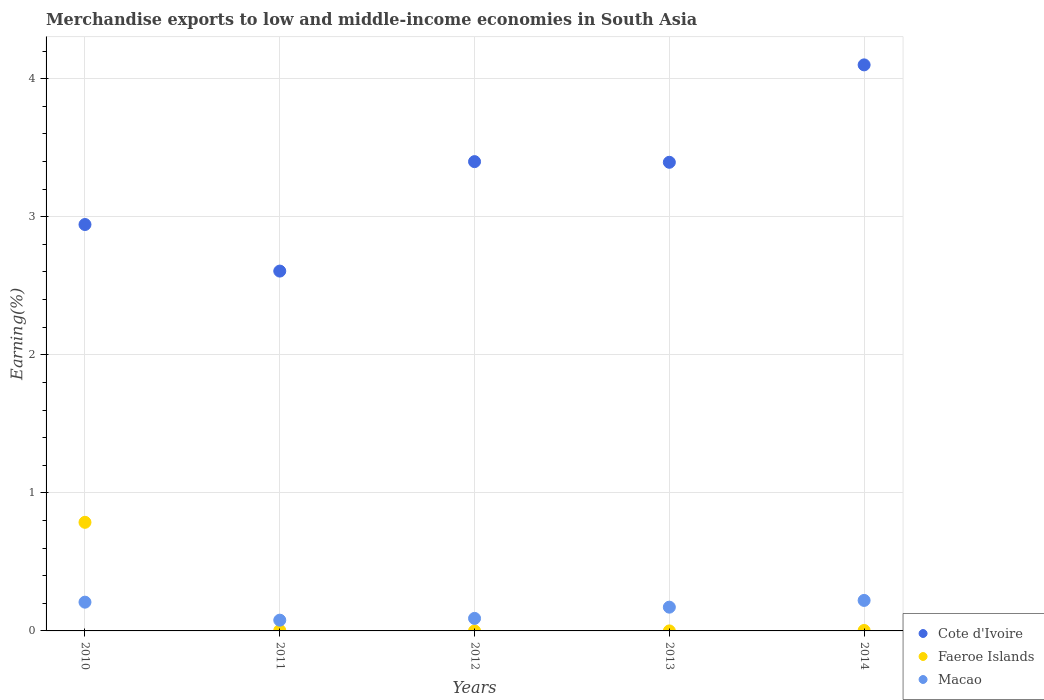Is the number of dotlines equal to the number of legend labels?
Give a very brief answer. Yes. What is the percentage of amount earned from merchandise exports in Faeroe Islands in 2010?
Your answer should be compact. 0.79. Across all years, what is the maximum percentage of amount earned from merchandise exports in Cote d'Ivoire?
Make the answer very short. 4.1. Across all years, what is the minimum percentage of amount earned from merchandise exports in Cote d'Ivoire?
Ensure brevity in your answer.  2.61. In which year was the percentage of amount earned from merchandise exports in Macao maximum?
Make the answer very short. 2014. What is the total percentage of amount earned from merchandise exports in Faeroe Islands in the graph?
Offer a terse response. 0.79. What is the difference between the percentage of amount earned from merchandise exports in Macao in 2010 and that in 2011?
Your response must be concise. 0.13. What is the difference between the percentage of amount earned from merchandise exports in Macao in 2012 and the percentage of amount earned from merchandise exports in Faeroe Islands in 2010?
Provide a short and direct response. -0.7. What is the average percentage of amount earned from merchandise exports in Macao per year?
Keep it short and to the point. 0.15. In the year 2013, what is the difference between the percentage of amount earned from merchandise exports in Faeroe Islands and percentage of amount earned from merchandise exports in Macao?
Your answer should be very brief. -0.17. In how many years, is the percentage of amount earned from merchandise exports in Macao greater than 3.6 %?
Provide a succinct answer. 0. What is the ratio of the percentage of amount earned from merchandise exports in Macao in 2010 to that in 2011?
Give a very brief answer. 2.67. Is the percentage of amount earned from merchandise exports in Macao in 2011 less than that in 2014?
Keep it short and to the point. Yes. What is the difference between the highest and the second highest percentage of amount earned from merchandise exports in Macao?
Keep it short and to the point. 0.01. What is the difference between the highest and the lowest percentage of amount earned from merchandise exports in Macao?
Make the answer very short. 0.14. In how many years, is the percentage of amount earned from merchandise exports in Cote d'Ivoire greater than the average percentage of amount earned from merchandise exports in Cote d'Ivoire taken over all years?
Provide a succinct answer. 3. Is the sum of the percentage of amount earned from merchandise exports in Cote d'Ivoire in 2011 and 2013 greater than the maximum percentage of amount earned from merchandise exports in Macao across all years?
Offer a very short reply. Yes. Is the percentage of amount earned from merchandise exports in Cote d'Ivoire strictly greater than the percentage of amount earned from merchandise exports in Macao over the years?
Offer a very short reply. Yes. Is the percentage of amount earned from merchandise exports in Faeroe Islands strictly less than the percentage of amount earned from merchandise exports in Macao over the years?
Provide a succinct answer. No. How many years are there in the graph?
Offer a very short reply. 5. Does the graph contain any zero values?
Provide a succinct answer. No. Does the graph contain grids?
Ensure brevity in your answer.  Yes. How many legend labels are there?
Make the answer very short. 3. How are the legend labels stacked?
Offer a very short reply. Vertical. What is the title of the graph?
Offer a terse response. Merchandise exports to low and middle-income economies in South Asia. Does "Luxembourg" appear as one of the legend labels in the graph?
Offer a very short reply. No. What is the label or title of the X-axis?
Your answer should be very brief. Years. What is the label or title of the Y-axis?
Your answer should be very brief. Earning(%). What is the Earning(%) in Cote d'Ivoire in 2010?
Ensure brevity in your answer.  2.94. What is the Earning(%) in Faeroe Islands in 2010?
Your answer should be very brief. 0.79. What is the Earning(%) of Macao in 2010?
Keep it short and to the point. 0.21. What is the Earning(%) of Cote d'Ivoire in 2011?
Provide a succinct answer. 2.61. What is the Earning(%) in Faeroe Islands in 2011?
Your answer should be very brief. 0. What is the Earning(%) in Macao in 2011?
Your answer should be compact. 0.08. What is the Earning(%) in Cote d'Ivoire in 2012?
Provide a short and direct response. 3.4. What is the Earning(%) of Faeroe Islands in 2012?
Give a very brief answer. 1.9199162385165e-5. What is the Earning(%) of Macao in 2012?
Ensure brevity in your answer.  0.09. What is the Earning(%) in Cote d'Ivoire in 2013?
Keep it short and to the point. 3.39. What is the Earning(%) in Faeroe Islands in 2013?
Your response must be concise. 3.45425076953635e-5. What is the Earning(%) of Macao in 2013?
Ensure brevity in your answer.  0.17. What is the Earning(%) in Cote d'Ivoire in 2014?
Your response must be concise. 4.1. What is the Earning(%) in Faeroe Islands in 2014?
Make the answer very short. 0. What is the Earning(%) of Macao in 2014?
Offer a terse response. 0.22. Across all years, what is the maximum Earning(%) of Cote d'Ivoire?
Your answer should be very brief. 4.1. Across all years, what is the maximum Earning(%) in Faeroe Islands?
Give a very brief answer. 0.79. Across all years, what is the maximum Earning(%) in Macao?
Your answer should be very brief. 0.22. Across all years, what is the minimum Earning(%) of Cote d'Ivoire?
Offer a terse response. 2.61. Across all years, what is the minimum Earning(%) of Faeroe Islands?
Ensure brevity in your answer.  1.9199162385165e-5. Across all years, what is the minimum Earning(%) of Macao?
Provide a succinct answer. 0.08. What is the total Earning(%) of Cote d'Ivoire in the graph?
Make the answer very short. 16.44. What is the total Earning(%) in Faeroe Islands in the graph?
Keep it short and to the point. 0.79. What is the total Earning(%) in Macao in the graph?
Offer a terse response. 0.77. What is the difference between the Earning(%) in Cote d'Ivoire in 2010 and that in 2011?
Provide a succinct answer. 0.34. What is the difference between the Earning(%) in Faeroe Islands in 2010 and that in 2011?
Ensure brevity in your answer.  0.78. What is the difference between the Earning(%) in Macao in 2010 and that in 2011?
Your answer should be compact. 0.13. What is the difference between the Earning(%) of Cote d'Ivoire in 2010 and that in 2012?
Offer a very short reply. -0.46. What is the difference between the Earning(%) of Faeroe Islands in 2010 and that in 2012?
Your response must be concise. 0.79. What is the difference between the Earning(%) of Macao in 2010 and that in 2012?
Provide a succinct answer. 0.12. What is the difference between the Earning(%) of Cote d'Ivoire in 2010 and that in 2013?
Your answer should be very brief. -0.45. What is the difference between the Earning(%) in Faeroe Islands in 2010 and that in 2013?
Your answer should be compact. 0.79. What is the difference between the Earning(%) in Macao in 2010 and that in 2013?
Keep it short and to the point. 0.04. What is the difference between the Earning(%) in Cote d'Ivoire in 2010 and that in 2014?
Make the answer very short. -1.16. What is the difference between the Earning(%) of Faeroe Islands in 2010 and that in 2014?
Provide a succinct answer. 0.78. What is the difference between the Earning(%) of Macao in 2010 and that in 2014?
Ensure brevity in your answer.  -0.01. What is the difference between the Earning(%) in Cote d'Ivoire in 2011 and that in 2012?
Keep it short and to the point. -0.79. What is the difference between the Earning(%) in Faeroe Islands in 2011 and that in 2012?
Provide a succinct answer. 0. What is the difference between the Earning(%) in Macao in 2011 and that in 2012?
Your answer should be compact. -0.01. What is the difference between the Earning(%) in Cote d'Ivoire in 2011 and that in 2013?
Your response must be concise. -0.79. What is the difference between the Earning(%) of Faeroe Islands in 2011 and that in 2013?
Provide a short and direct response. 0. What is the difference between the Earning(%) of Macao in 2011 and that in 2013?
Offer a very short reply. -0.09. What is the difference between the Earning(%) of Cote d'Ivoire in 2011 and that in 2014?
Ensure brevity in your answer.  -1.49. What is the difference between the Earning(%) in Macao in 2011 and that in 2014?
Ensure brevity in your answer.  -0.14. What is the difference between the Earning(%) in Cote d'Ivoire in 2012 and that in 2013?
Give a very brief answer. 0. What is the difference between the Earning(%) of Faeroe Islands in 2012 and that in 2013?
Provide a succinct answer. -0. What is the difference between the Earning(%) of Macao in 2012 and that in 2013?
Offer a very short reply. -0.08. What is the difference between the Earning(%) in Cote d'Ivoire in 2012 and that in 2014?
Keep it short and to the point. -0.7. What is the difference between the Earning(%) in Faeroe Islands in 2012 and that in 2014?
Keep it short and to the point. -0. What is the difference between the Earning(%) in Macao in 2012 and that in 2014?
Give a very brief answer. -0.13. What is the difference between the Earning(%) in Cote d'Ivoire in 2013 and that in 2014?
Keep it short and to the point. -0.71. What is the difference between the Earning(%) of Faeroe Islands in 2013 and that in 2014?
Provide a short and direct response. -0. What is the difference between the Earning(%) of Macao in 2013 and that in 2014?
Provide a short and direct response. -0.05. What is the difference between the Earning(%) of Cote d'Ivoire in 2010 and the Earning(%) of Faeroe Islands in 2011?
Provide a succinct answer. 2.94. What is the difference between the Earning(%) in Cote d'Ivoire in 2010 and the Earning(%) in Macao in 2011?
Provide a short and direct response. 2.87. What is the difference between the Earning(%) in Faeroe Islands in 2010 and the Earning(%) in Macao in 2011?
Keep it short and to the point. 0.71. What is the difference between the Earning(%) in Cote d'Ivoire in 2010 and the Earning(%) in Faeroe Islands in 2012?
Your answer should be compact. 2.94. What is the difference between the Earning(%) of Cote d'Ivoire in 2010 and the Earning(%) of Macao in 2012?
Offer a very short reply. 2.85. What is the difference between the Earning(%) of Faeroe Islands in 2010 and the Earning(%) of Macao in 2012?
Make the answer very short. 0.7. What is the difference between the Earning(%) in Cote d'Ivoire in 2010 and the Earning(%) in Faeroe Islands in 2013?
Offer a very short reply. 2.94. What is the difference between the Earning(%) in Cote d'Ivoire in 2010 and the Earning(%) in Macao in 2013?
Ensure brevity in your answer.  2.77. What is the difference between the Earning(%) of Faeroe Islands in 2010 and the Earning(%) of Macao in 2013?
Provide a short and direct response. 0.61. What is the difference between the Earning(%) in Cote d'Ivoire in 2010 and the Earning(%) in Faeroe Islands in 2014?
Offer a terse response. 2.94. What is the difference between the Earning(%) of Cote d'Ivoire in 2010 and the Earning(%) of Macao in 2014?
Your response must be concise. 2.72. What is the difference between the Earning(%) in Faeroe Islands in 2010 and the Earning(%) in Macao in 2014?
Provide a succinct answer. 0.57. What is the difference between the Earning(%) of Cote d'Ivoire in 2011 and the Earning(%) of Faeroe Islands in 2012?
Your answer should be compact. 2.61. What is the difference between the Earning(%) of Cote d'Ivoire in 2011 and the Earning(%) of Macao in 2012?
Ensure brevity in your answer.  2.52. What is the difference between the Earning(%) in Faeroe Islands in 2011 and the Earning(%) in Macao in 2012?
Provide a short and direct response. -0.09. What is the difference between the Earning(%) in Cote d'Ivoire in 2011 and the Earning(%) in Faeroe Islands in 2013?
Ensure brevity in your answer.  2.61. What is the difference between the Earning(%) of Cote d'Ivoire in 2011 and the Earning(%) of Macao in 2013?
Give a very brief answer. 2.43. What is the difference between the Earning(%) in Faeroe Islands in 2011 and the Earning(%) in Macao in 2013?
Provide a succinct answer. -0.17. What is the difference between the Earning(%) in Cote d'Ivoire in 2011 and the Earning(%) in Faeroe Islands in 2014?
Provide a succinct answer. 2.6. What is the difference between the Earning(%) of Cote d'Ivoire in 2011 and the Earning(%) of Macao in 2014?
Make the answer very short. 2.39. What is the difference between the Earning(%) in Faeroe Islands in 2011 and the Earning(%) in Macao in 2014?
Provide a succinct answer. -0.22. What is the difference between the Earning(%) of Cote d'Ivoire in 2012 and the Earning(%) of Faeroe Islands in 2013?
Provide a short and direct response. 3.4. What is the difference between the Earning(%) of Cote d'Ivoire in 2012 and the Earning(%) of Macao in 2013?
Ensure brevity in your answer.  3.23. What is the difference between the Earning(%) in Faeroe Islands in 2012 and the Earning(%) in Macao in 2013?
Keep it short and to the point. -0.17. What is the difference between the Earning(%) of Cote d'Ivoire in 2012 and the Earning(%) of Faeroe Islands in 2014?
Give a very brief answer. 3.4. What is the difference between the Earning(%) in Cote d'Ivoire in 2012 and the Earning(%) in Macao in 2014?
Your answer should be very brief. 3.18. What is the difference between the Earning(%) in Faeroe Islands in 2012 and the Earning(%) in Macao in 2014?
Ensure brevity in your answer.  -0.22. What is the difference between the Earning(%) of Cote d'Ivoire in 2013 and the Earning(%) of Faeroe Islands in 2014?
Provide a succinct answer. 3.39. What is the difference between the Earning(%) of Cote d'Ivoire in 2013 and the Earning(%) of Macao in 2014?
Offer a very short reply. 3.17. What is the difference between the Earning(%) of Faeroe Islands in 2013 and the Earning(%) of Macao in 2014?
Offer a very short reply. -0.22. What is the average Earning(%) in Cote d'Ivoire per year?
Make the answer very short. 3.29. What is the average Earning(%) of Faeroe Islands per year?
Offer a terse response. 0.16. What is the average Earning(%) in Macao per year?
Give a very brief answer. 0.15. In the year 2010, what is the difference between the Earning(%) in Cote d'Ivoire and Earning(%) in Faeroe Islands?
Your answer should be very brief. 2.16. In the year 2010, what is the difference between the Earning(%) in Cote d'Ivoire and Earning(%) in Macao?
Ensure brevity in your answer.  2.74. In the year 2010, what is the difference between the Earning(%) in Faeroe Islands and Earning(%) in Macao?
Ensure brevity in your answer.  0.58. In the year 2011, what is the difference between the Earning(%) in Cote d'Ivoire and Earning(%) in Faeroe Islands?
Give a very brief answer. 2.6. In the year 2011, what is the difference between the Earning(%) in Cote d'Ivoire and Earning(%) in Macao?
Provide a short and direct response. 2.53. In the year 2011, what is the difference between the Earning(%) in Faeroe Islands and Earning(%) in Macao?
Give a very brief answer. -0.07. In the year 2012, what is the difference between the Earning(%) of Cote d'Ivoire and Earning(%) of Faeroe Islands?
Keep it short and to the point. 3.4. In the year 2012, what is the difference between the Earning(%) in Cote d'Ivoire and Earning(%) in Macao?
Offer a very short reply. 3.31. In the year 2012, what is the difference between the Earning(%) of Faeroe Islands and Earning(%) of Macao?
Make the answer very short. -0.09. In the year 2013, what is the difference between the Earning(%) in Cote d'Ivoire and Earning(%) in Faeroe Islands?
Offer a terse response. 3.39. In the year 2013, what is the difference between the Earning(%) of Cote d'Ivoire and Earning(%) of Macao?
Provide a short and direct response. 3.22. In the year 2013, what is the difference between the Earning(%) of Faeroe Islands and Earning(%) of Macao?
Provide a short and direct response. -0.17. In the year 2014, what is the difference between the Earning(%) of Cote d'Ivoire and Earning(%) of Faeroe Islands?
Offer a very short reply. 4.1. In the year 2014, what is the difference between the Earning(%) in Cote d'Ivoire and Earning(%) in Macao?
Keep it short and to the point. 3.88. In the year 2014, what is the difference between the Earning(%) in Faeroe Islands and Earning(%) in Macao?
Keep it short and to the point. -0.22. What is the ratio of the Earning(%) in Cote d'Ivoire in 2010 to that in 2011?
Give a very brief answer. 1.13. What is the ratio of the Earning(%) in Faeroe Islands in 2010 to that in 2011?
Offer a terse response. 228.91. What is the ratio of the Earning(%) of Macao in 2010 to that in 2011?
Give a very brief answer. 2.67. What is the ratio of the Earning(%) of Cote d'Ivoire in 2010 to that in 2012?
Your response must be concise. 0.87. What is the ratio of the Earning(%) of Faeroe Islands in 2010 to that in 2012?
Ensure brevity in your answer.  4.10e+04. What is the ratio of the Earning(%) in Macao in 2010 to that in 2012?
Offer a terse response. 2.3. What is the ratio of the Earning(%) in Cote d'Ivoire in 2010 to that in 2013?
Your answer should be compact. 0.87. What is the ratio of the Earning(%) of Faeroe Islands in 2010 to that in 2013?
Your answer should be compact. 2.28e+04. What is the ratio of the Earning(%) in Macao in 2010 to that in 2013?
Keep it short and to the point. 1.21. What is the ratio of the Earning(%) in Cote d'Ivoire in 2010 to that in 2014?
Provide a succinct answer. 0.72. What is the ratio of the Earning(%) in Faeroe Islands in 2010 to that in 2014?
Your answer should be compact. 239.87. What is the ratio of the Earning(%) of Macao in 2010 to that in 2014?
Your response must be concise. 0.94. What is the ratio of the Earning(%) of Cote d'Ivoire in 2011 to that in 2012?
Give a very brief answer. 0.77. What is the ratio of the Earning(%) of Faeroe Islands in 2011 to that in 2012?
Offer a very short reply. 178.97. What is the ratio of the Earning(%) in Macao in 2011 to that in 2012?
Provide a succinct answer. 0.86. What is the ratio of the Earning(%) of Cote d'Ivoire in 2011 to that in 2013?
Keep it short and to the point. 0.77. What is the ratio of the Earning(%) in Faeroe Islands in 2011 to that in 2013?
Provide a short and direct response. 99.47. What is the ratio of the Earning(%) of Macao in 2011 to that in 2013?
Give a very brief answer. 0.45. What is the ratio of the Earning(%) of Cote d'Ivoire in 2011 to that in 2014?
Provide a short and direct response. 0.64. What is the ratio of the Earning(%) in Faeroe Islands in 2011 to that in 2014?
Your answer should be very brief. 1.05. What is the ratio of the Earning(%) of Macao in 2011 to that in 2014?
Provide a short and direct response. 0.35. What is the ratio of the Earning(%) of Faeroe Islands in 2012 to that in 2013?
Your response must be concise. 0.56. What is the ratio of the Earning(%) in Macao in 2012 to that in 2013?
Offer a terse response. 0.53. What is the ratio of the Earning(%) in Cote d'Ivoire in 2012 to that in 2014?
Make the answer very short. 0.83. What is the ratio of the Earning(%) of Faeroe Islands in 2012 to that in 2014?
Your response must be concise. 0.01. What is the ratio of the Earning(%) in Macao in 2012 to that in 2014?
Keep it short and to the point. 0.41. What is the ratio of the Earning(%) in Cote d'Ivoire in 2013 to that in 2014?
Make the answer very short. 0.83. What is the ratio of the Earning(%) of Faeroe Islands in 2013 to that in 2014?
Provide a succinct answer. 0.01. What is the ratio of the Earning(%) in Macao in 2013 to that in 2014?
Ensure brevity in your answer.  0.78. What is the difference between the highest and the second highest Earning(%) of Cote d'Ivoire?
Keep it short and to the point. 0.7. What is the difference between the highest and the second highest Earning(%) in Faeroe Islands?
Your answer should be compact. 0.78. What is the difference between the highest and the second highest Earning(%) in Macao?
Offer a very short reply. 0.01. What is the difference between the highest and the lowest Earning(%) in Cote d'Ivoire?
Ensure brevity in your answer.  1.49. What is the difference between the highest and the lowest Earning(%) of Faeroe Islands?
Provide a short and direct response. 0.79. What is the difference between the highest and the lowest Earning(%) in Macao?
Offer a very short reply. 0.14. 